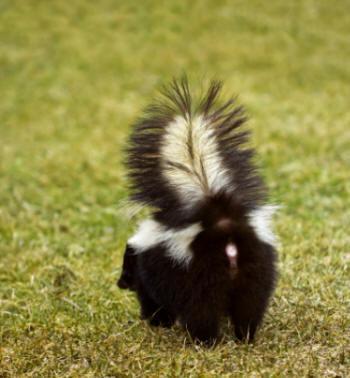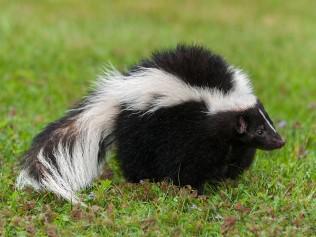The first image is the image on the left, the second image is the image on the right. Evaluate the accuracy of this statement regarding the images: "There are two skunks facing right.". Is it true? Answer yes or no. No. 